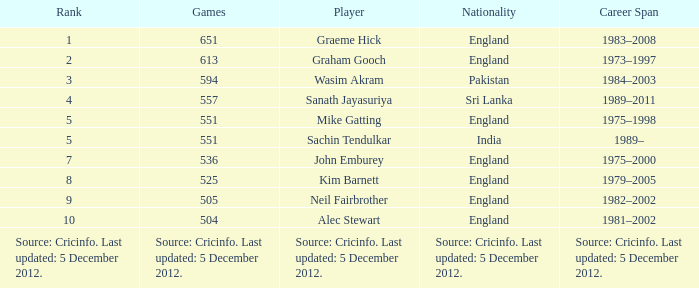What is the Nationality of Mike Gatting, who played 551 games? England. 